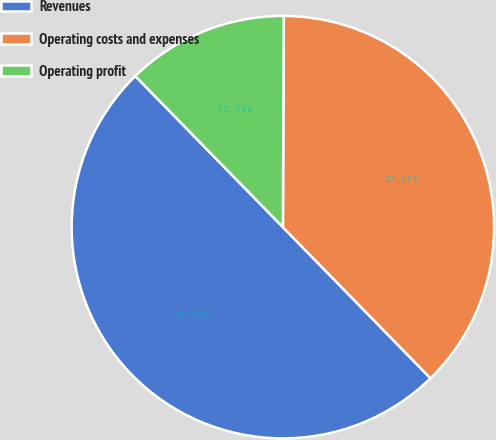Convert chart to OTSL. <chart><loc_0><loc_0><loc_500><loc_500><pie_chart><fcel>Revenues<fcel>Operating costs and expenses<fcel>Operating profit<nl><fcel>50.0%<fcel>37.62%<fcel>12.38%<nl></chart> 